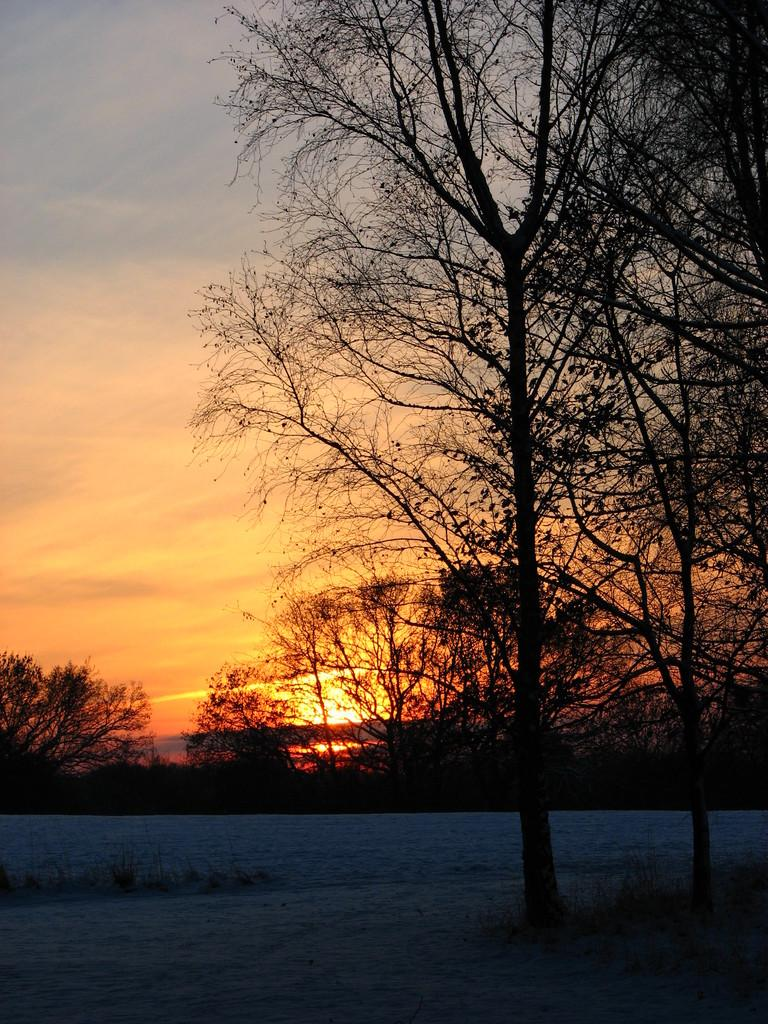What type of vegetation can be seen in the image? There are trees in the image. What is visible in the background of the image? There is a sky visible in the background of the image. How many letters does the aunt hold in the image? There is no aunt or letters present in the image. How many chairs are visible in the image? There are no chairs visible in the image. 